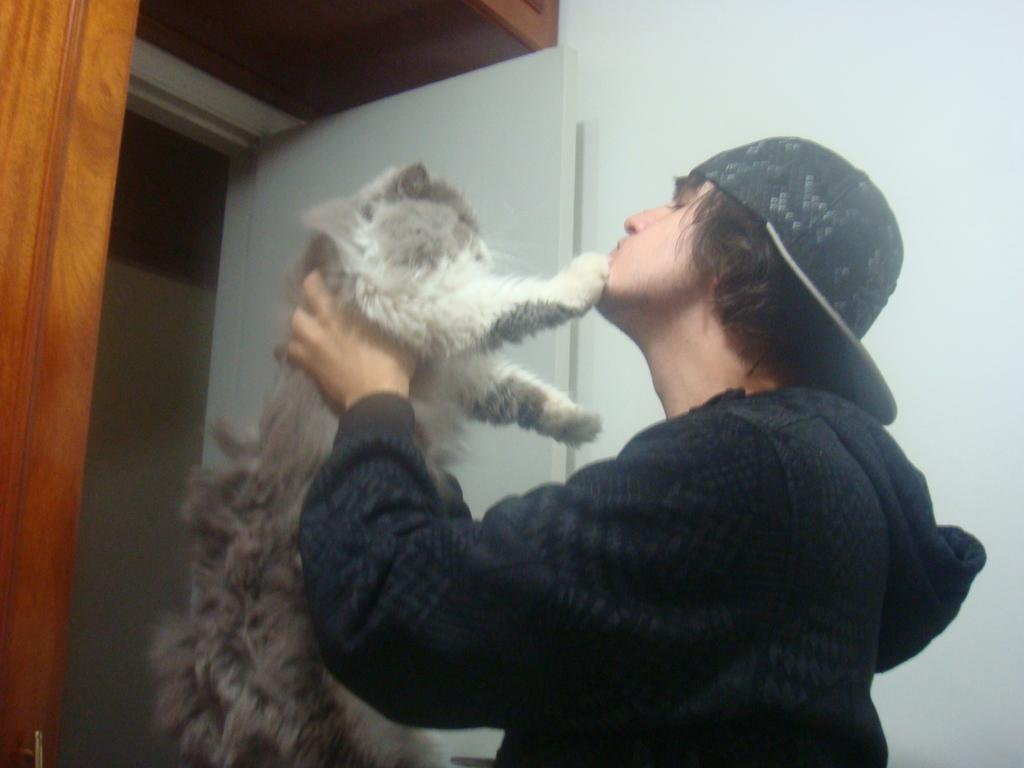What is the main subject of the image? There is a person in the image. What is the person holding in the image? The person is holding a cat. What can be seen in the background of the image? There is a wall and a door in the image. What type of grip does the donkey have on the door in the image? There is no donkey present in the image, and therefore no grip on the door can be observed. 